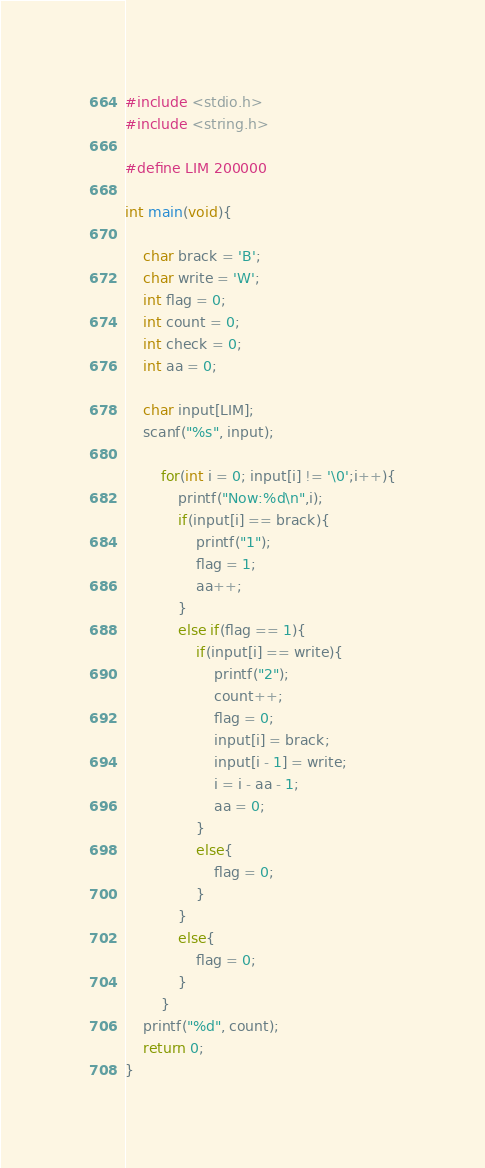Convert code to text. <code><loc_0><loc_0><loc_500><loc_500><_C_>#include <stdio.h>
#include <string.h>

#define LIM 200000

int main(void){

    char brack = 'B';
    char write = 'W';
    int flag = 0;
    int count = 0;
    int check = 0;
    int aa = 0;

    char input[LIM];
    scanf("%s", input);

        for(int i = 0; input[i] != '\0';i++){
            printf("Now:%d\n",i);
            if(input[i] == brack){
                printf("1");
                flag = 1;
                aa++;
            }
            else if(flag == 1){
                if(input[i] == write){
                    printf("2");
                    count++;
                    flag = 0;
                    input[i] = brack;
                    input[i - 1] = write;
                    i = i - aa - 1;
                    aa = 0;
                }
                else{
                    flag = 0;
                }
            }
            else{
                flag = 0;
            }
        }
    printf("%d", count);
    return 0;
}</code> 